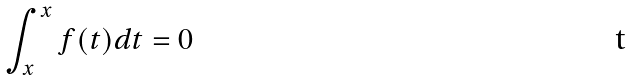<formula> <loc_0><loc_0><loc_500><loc_500>\int _ { x } ^ { x } f ( t ) d t = 0</formula> 